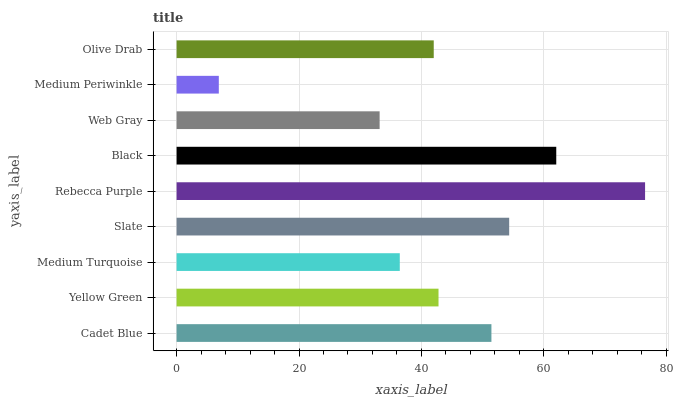Is Medium Periwinkle the minimum?
Answer yes or no. Yes. Is Rebecca Purple the maximum?
Answer yes or no. Yes. Is Yellow Green the minimum?
Answer yes or no. No. Is Yellow Green the maximum?
Answer yes or no. No. Is Cadet Blue greater than Yellow Green?
Answer yes or no. Yes. Is Yellow Green less than Cadet Blue?
Answer yes or no. Yes. Is Yellow Green greater than Cadet Blue?
Answer yes or no. No. Is Cadet Blue less than Yellow Green?
Answer yes or no. No. Is Yellow Green the high median?
Answer yes or no. Yes. Is Yellow Green the low median?
Answer yes or no. Yes. Is Slate the high median?
Answer yes or no. No. Is Rebecca Purple the low median?
Answer yes or no. No. 